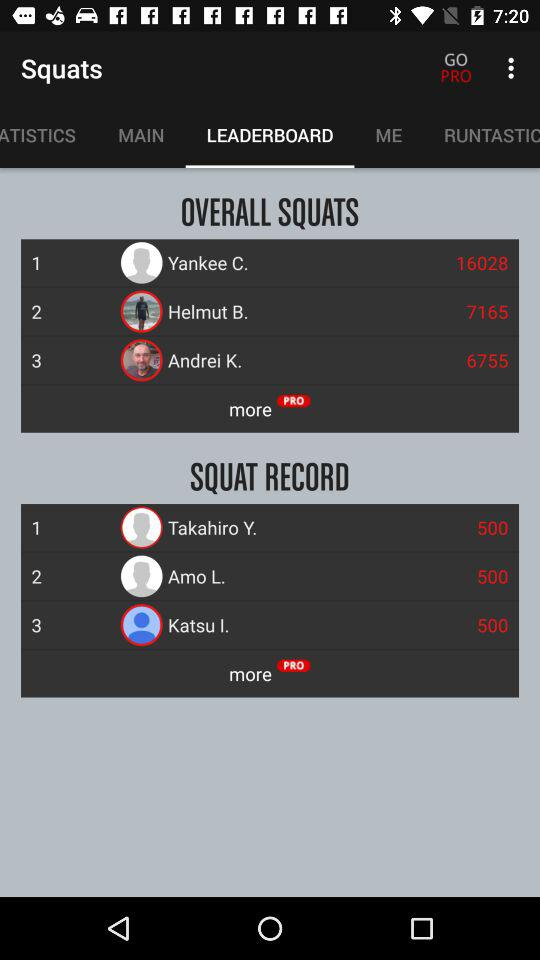What is the squat record of Takahiro Y.? The squat record of Takahiro Y. is 500. 